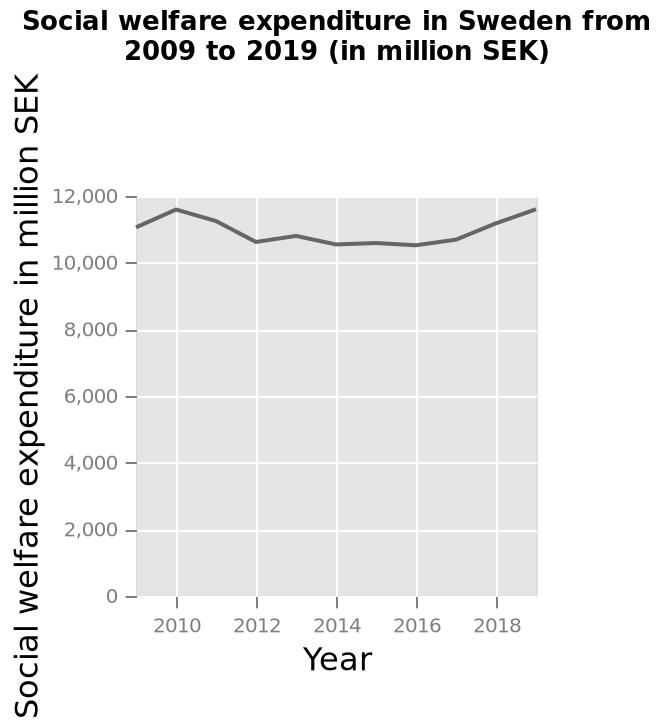<image>
What unit is used to measure the social welfare expenditure? The social welfare expenditure is measured in million Swedish Kronor (SEK). 